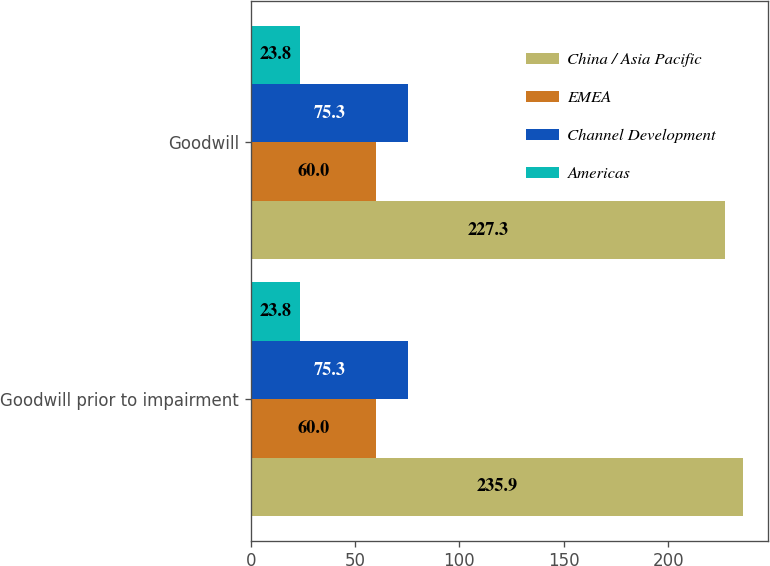Convert chart. <chart><loc_0><loc_0><loc_500><loc_500><stacked_bar_chart><ecel><fcel>Goodwill prior to impairment<fcel>Goodwill<nl><fcel>China / Asia Pacific<fcel>235.9<fcel>227.3<nl><fcel>EMEA<fcel>60<fcel>60<nl><fcel>Channel Development<fcel>75.3<fcel>75.3<nl><fcel>Americas<fcel>23.8<fcel>23.8<nl></chart> 